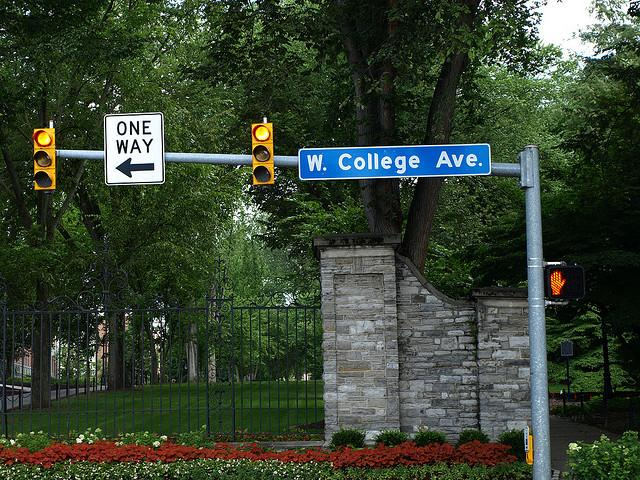What color is the light shown on top of the traffic lights of College Avenue?

Choices:
A) blue
B) yellow
C) red
D) green yellow 